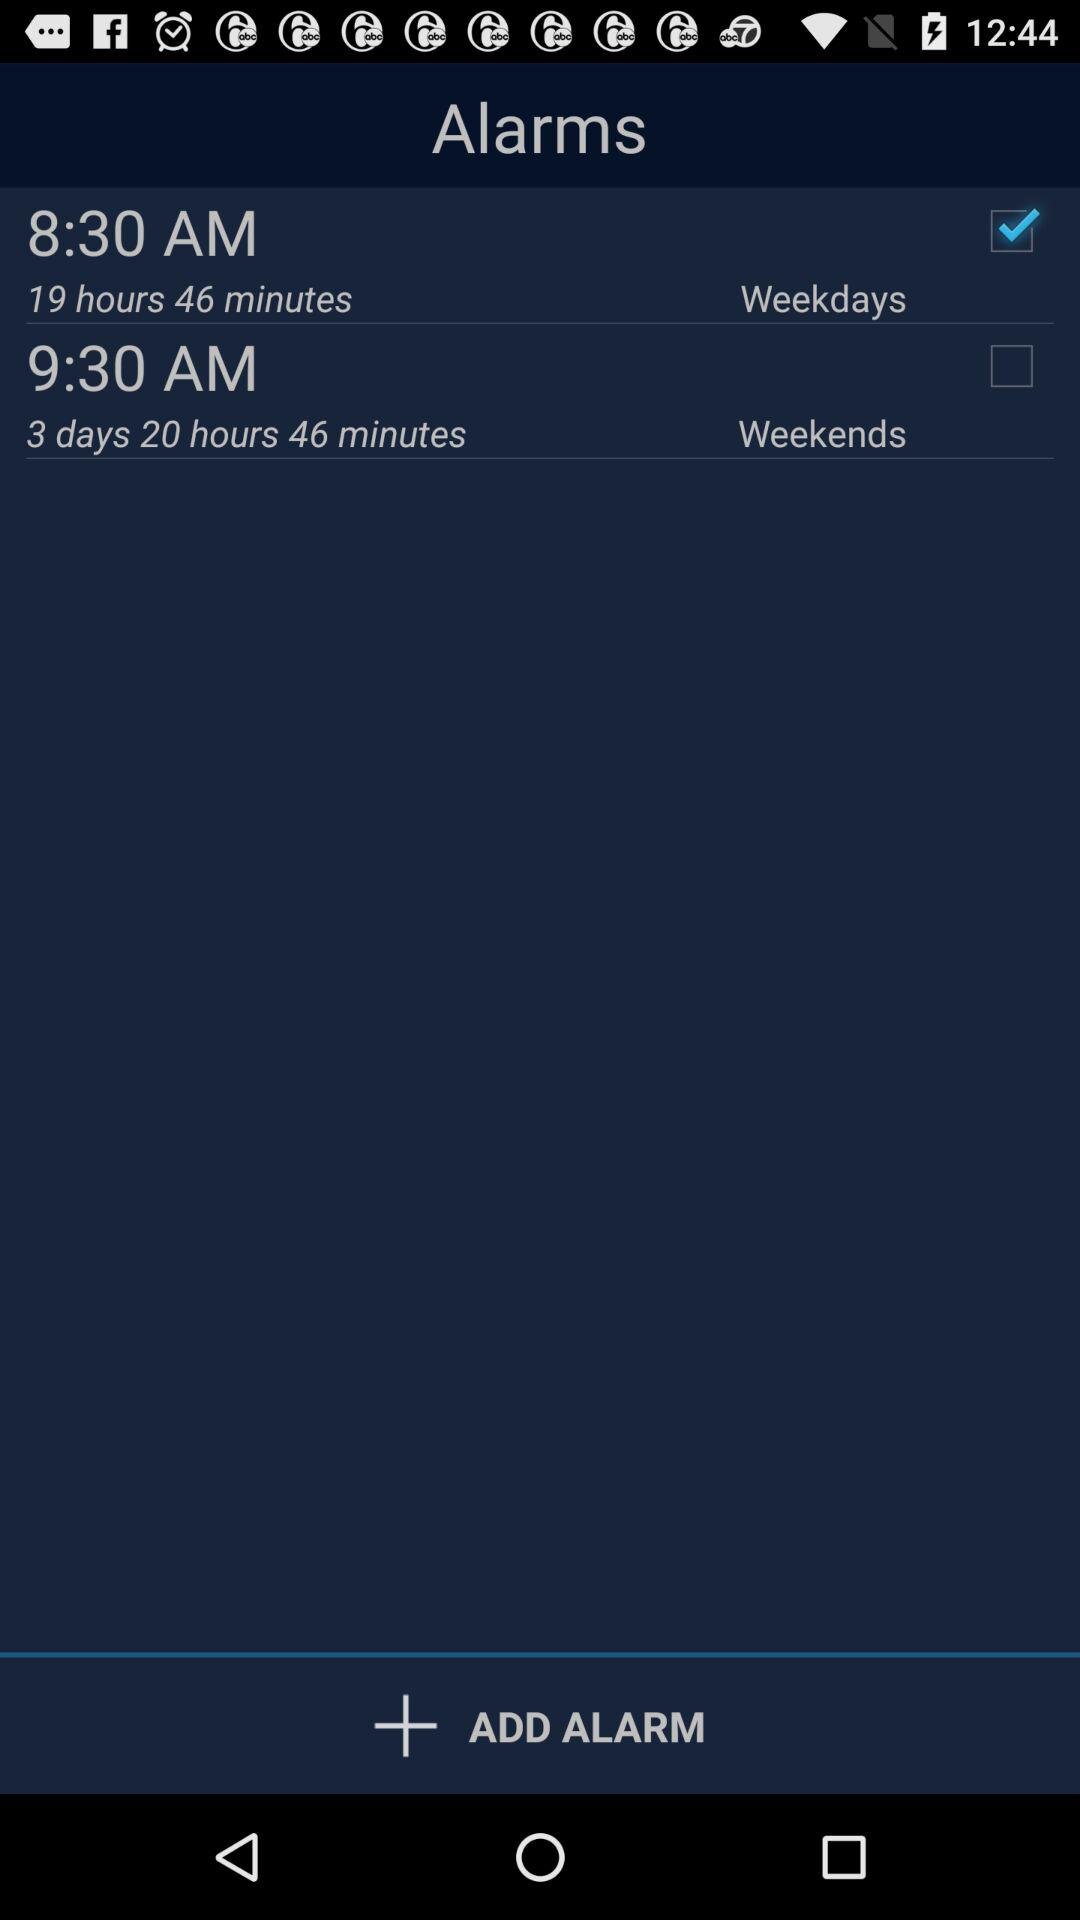How many alarms are there?
Answer the question using a single word or phrase. 2 